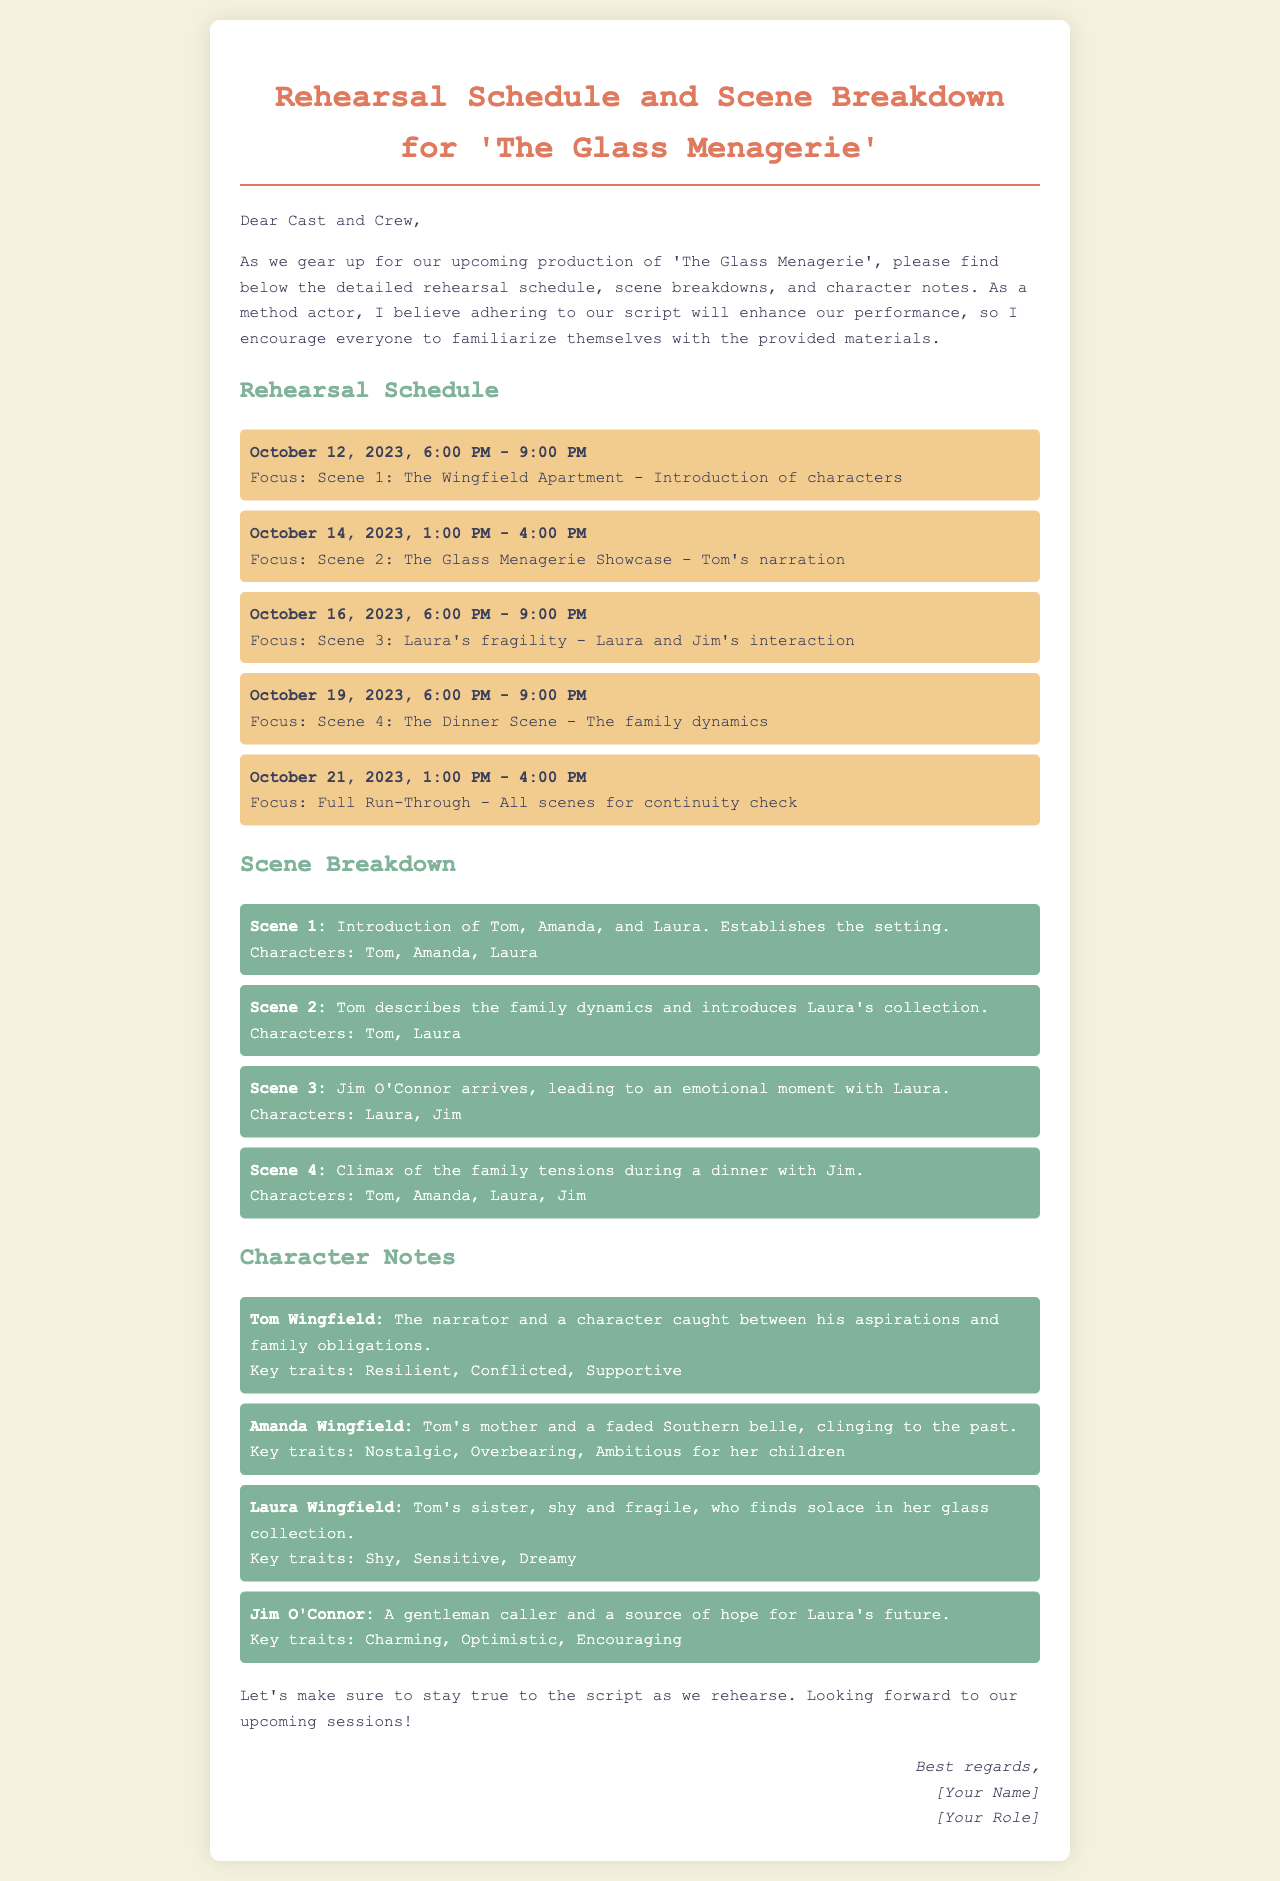What is the title of the play? The title of the play is specified at the beginning of the document.
Answer: The Glass Menagerie What is the focus of the rehearsal on October 14, 2023? The focus is detailed under the specific date in the rehearsal schedule section.
Answer: Scene 2: The Glass Menagerie Showcase - Tom's narration How many scenes are outlined in the scene breakdown? The total number of scenes can be counted in the scene breakdown section.
Answer: 4 Who is the character described as "Tom's sister, shy and fragile"? This description can be found in the character notes section.
Answer: Laura Wingfield What is the time duration of the rehearsal on October 21, 2023? The duration is given for the specific date in the rehearsal schedule section.
Answer: 3 hours What key trait is associated with Amanda Wingfield? This trait is listed under Amanda's character notes.
Answer: Overbearing What is the key focus of Scene 4? The focus is mentioned in the scene breakdown section.
Answer: Climax of the family tensions during a dinner with Jim What is the start time for the rehearsal on October 19, 2023? The start time is specified under that date in the rehearsal schedule.
Answer: 6:00 PM What role does Tom Wingfield play in the story? The role is described in the character notes section.
Answer: The narrator and a character caught between his aspirations and family obligations 